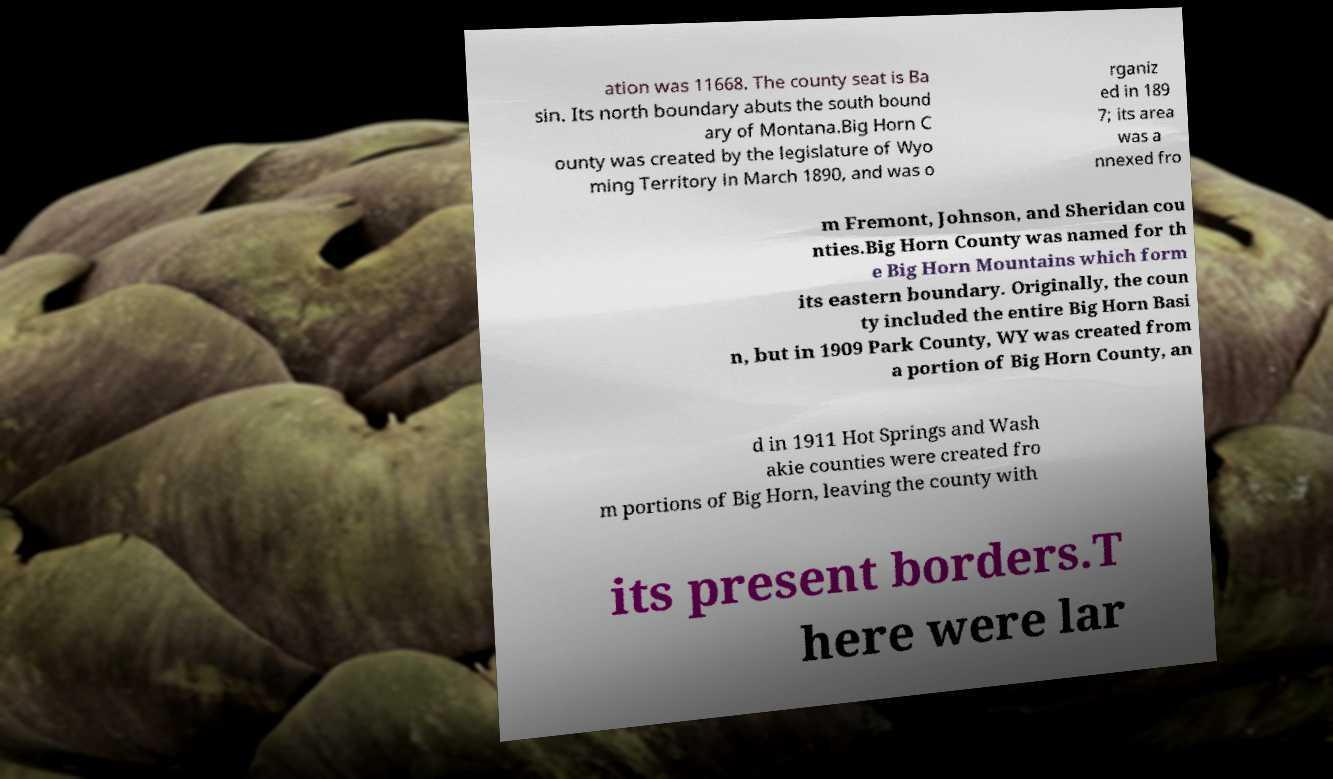Could you extract and type out the text from this image? ation was 11668. The county seat is Ba sin. Its north boundary abuts the south bound ary of Montana.Big Horn C ounty was created by the legislature of Wyo ming Territory in March 1890, and was o rganiz ed in 189 7; its area was a nnexed fro m Fremont, Johnson, and Sheridan cou nties.Big Horn County was named for th e Big Horn Mountains which form its eastern boundary. Originally, the coun ty included the entire Big Horn Basi n, but in 1909 Park County, WY was created from a portion of Big Horn County, an d in 1911 Hot Springs and Wash akie counties were created fro m portions of Big Horn, leaving the county with its present borders.T here were lar 